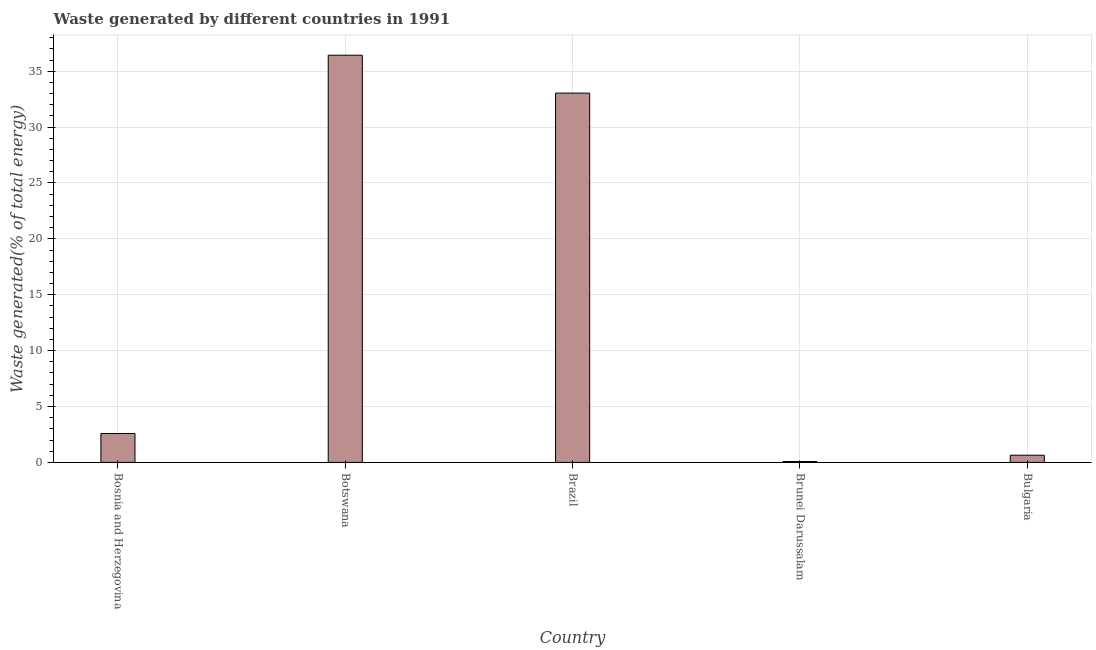Does the graph contain any zero values?
Provide a short and direct response. No. Does the graph contain grids?
Offer a very short reply. Yes. What is the title of the graph?
Offer a terse response. Waste generated by different countries in 1991. What is the label or title of the X-axis?
Keep it short and to the point. Country. What is the label or title of the Y-axis?
Offer a very short reply. Waste generated(% of total energy). What is the amount of waste generated in Botswana?
Make the answer very short. 36.43. Across all countries, what is the maximum amount of waste generated?
Ensure brevity in your answer.  36.43. Across all countries, what is the minimum amount of waste generated?
Give a very brief answer. 0.08. In which country was the amount of waste generated maximum?
Ensure brevity in your answer.  Botswana. In which country was the amount of waste generated minimum?
Give a very brief answer. Brunei Darussalam. What is the sum of the amount of waste generated?
Give a very brief answer. 72.78. What is the difference between the amount of waste generated in Bosnia and Herzegovina and Brunei Darussalam?
Offer a terse response. 2.51. What is the average amount of waste generated per country?
Offer a terse response. 14.56. What is the median amount of waste generated?
Ensure brevity in your answer.  2.59. What is the ratio of the amount of waste generated in Brunei Darussalam to that in Bulgaria?
Keep it short and to the point. 0.12. What is the difference between the highest and the second highest amount of waste generated?
Ensure brevity in your answer.  3.39. Is the sum of the amount of waste generated in Brazil and Bulgaria greater than the maximum amount of waste generated across all countries?
Give a very brief answer. No. What is the difference between the highest and the lowest amount of waste generated?
Your answer should be very brief. 36.35. How many bars are there?
Ensure brevity in your answer.  5. How many countries are there in the graph?
Your answer should be very brief. 5. What is the difference between two consecutive major ticks on the Y-axis?
Offer a terse response. 5. What is the Waste generated(% of total energy) in Bosnia and Herzegovina?
Make the answer very short. 2.59. What is the Waste generated(% of total energy) in Botswana?
Your answer should be compact. 36.43. What is the Waste generated(% of total energy) in Brazil?
Give a very brief answer. 33.04. What is the Waste generated(% of total energy) of Brunei Darussalam?
Offer a terse response. 0.08. What is the Waste generated(% of total energy) in Bulgaria?
Provide a succinct answer. 0.64. What is the difference between the Waste generated(% of total energy) in Bosnia and Herzegovina and Botswana?
Keep it short and to the point. -33.84. What is the difference between the Waste generated(% of total energy) in Bosnia and Herzegovina and Brazil?
Your answer should be very brief. -30.46. What is the difference between the Waste generated(% of total energy) in Bosnia and Herzegovina and Brunei Darussalam?
Provide a short and direct response. 2.51. What is the difference between the Waste generated(% of total energy) in Bosnia and Herzegovina and Bulgaria?
Keep it short and to the point. 1.94. What is the difference between the Waste generated(% of total energy) in Botswana and Brazil?
Offer a terse response. 3.39. What is the difference between the Waste generated(% of total energy) in Botswana and Brunei Darussalam?
Make the answer very short. 36.35. What is the difference between the Waste generated(% of total energy) in Botswana and Bulgaria?
Provide a short and direct response. 35.79. What is the difference between the Waste generated(% of total energy) in Brazil and Brunei Darussalam?
Your answer should be compact. 32.96. What is the difference between the Waste generated(% of total energy) in Brazil and Bulgaria?
Make the answer very short. 32.4. What is the difference between the Waste generated(% of total energy) in Brunei Darussalam and Bulgaria?
Your answer should be compact. -0.56. What is the ratio of the Waste generated(% of total energy) in Bosnia and Herzegovina to that in Botswana?
Your response must be concise. 0.07. What is the ratio of the Waste generated(% of total energy) in Bosnia and Herzegovina to that in Brazil?
Make the answer very short. 0.08. What is the ratio of the Waste generated(% of total energy) in Bosnia and Herzegovina to that in Brunei Darussalam?
Give a very brief answer. 33.04. What is the ratio of the Waste generated(% of total energy) in Bosnia and Herzegovina to that in Bulgaria?
Offer a very short reply. 4.02. What is the ratio of the Waste generated(% of total energy) in Botswana to that in Brazil?
Offer a terse response. 1.1. What is the ratio of the Waste generated(% of total energy) in Botswana to that in Brunei Darussalam?
Make the answer very short. 465.56. What is the ratio of the Waste generated(% of total energy) in Botswana to that in Bulgaria?
Ensure brevity in your answer.  56.65. What is the ratio of the Waste generated(% of total energy) in Brazil to that in Brunei Darussalam?
Offer a very short reply. 422.26. What is the ratio of the Waste generated(% of total energy) in Brazil to that in Bulgaria?
Your answer should be compact. 51.38. What is the ratio of the Waste generated(% of total energy) in Brunei Darussalam to that in Bulgaria?
Your answer should be very brief. 0.12. 